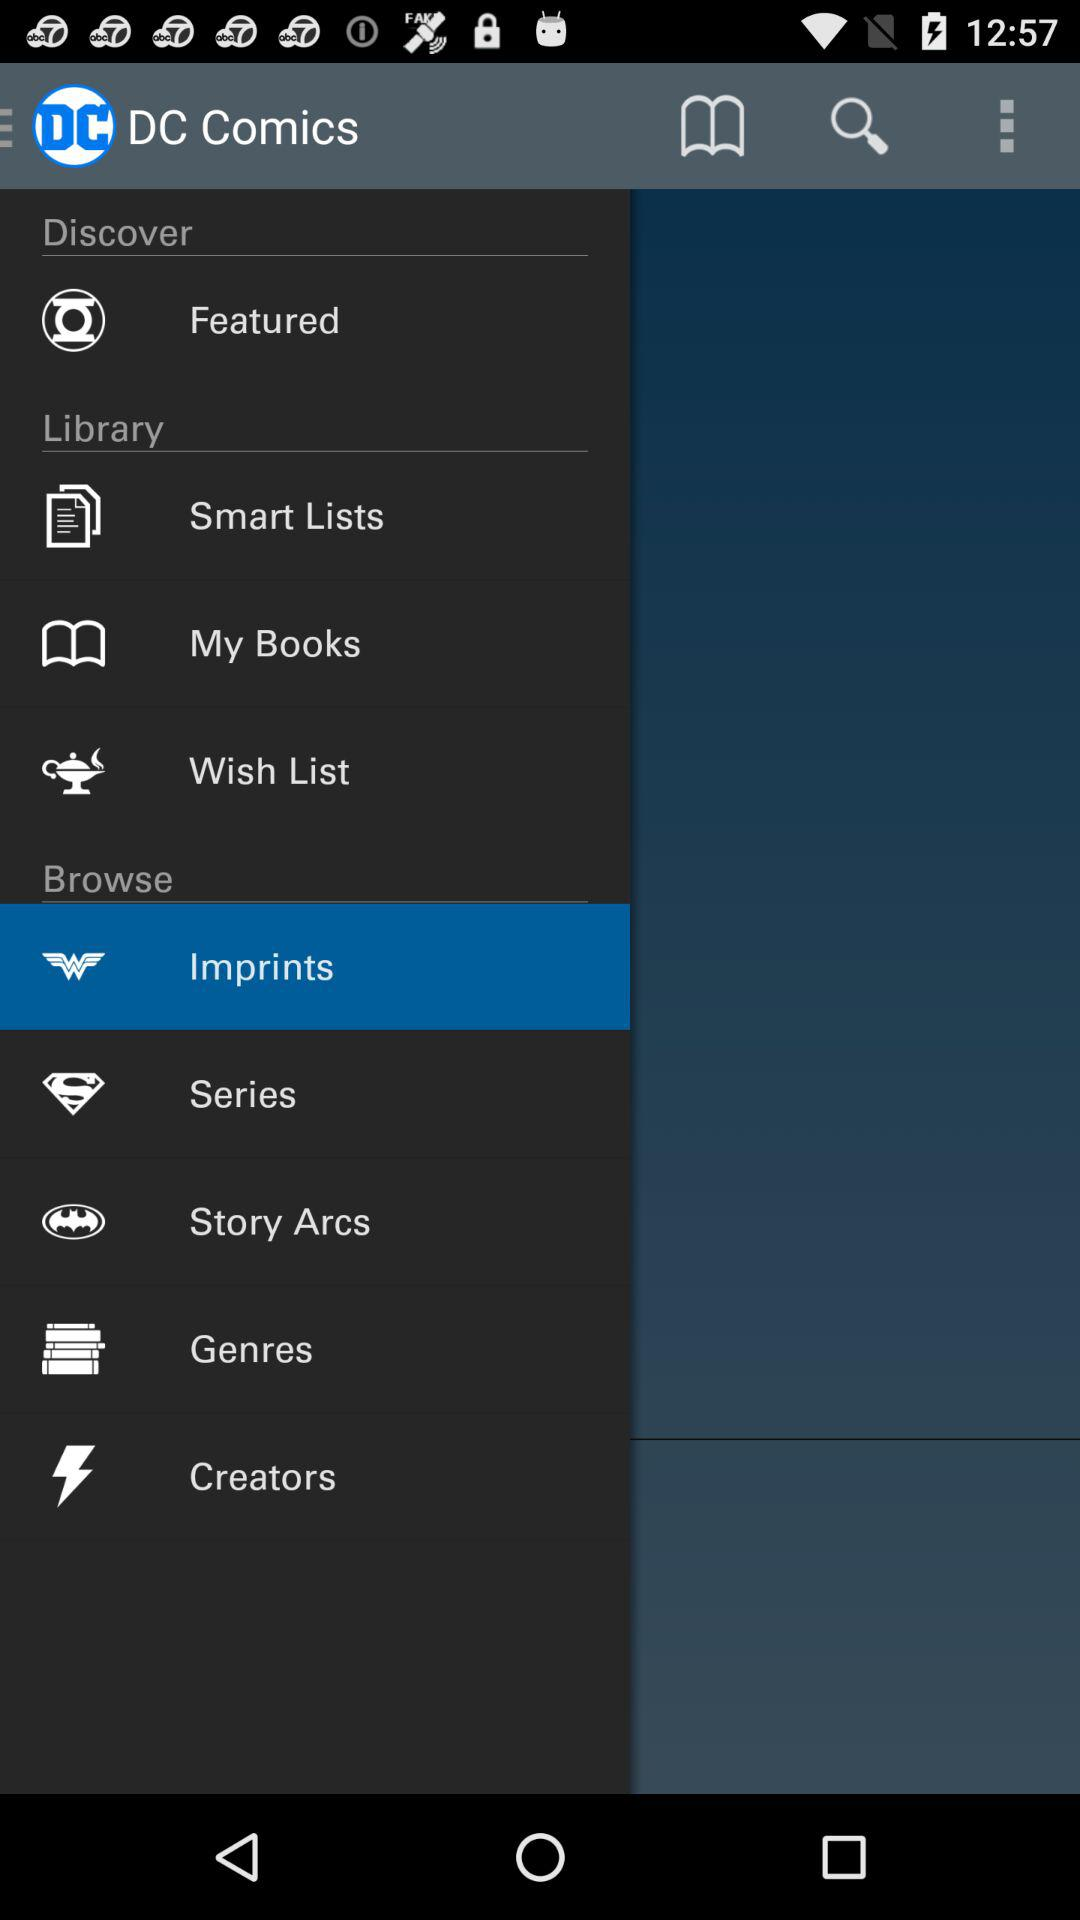What is the app name? The app name is "DC Comics". 